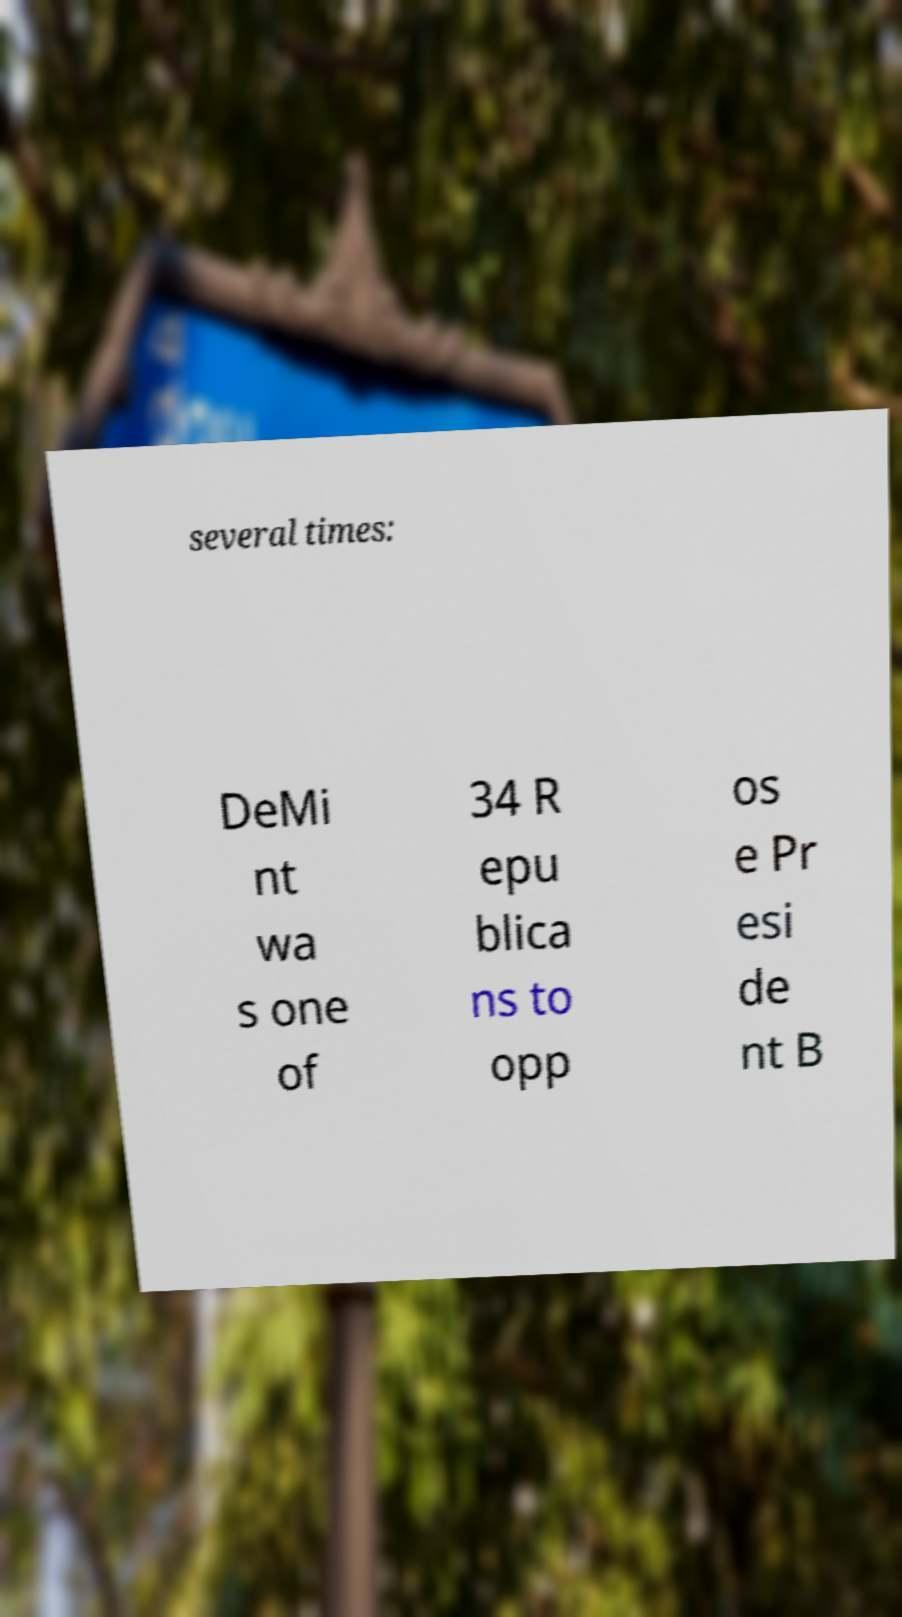What messages or text are displayed in this image? I need them in a readable, typed format. several times: DeMi nt wa s one of 34 R epu blica ns to opp os e Pr esi de nt B 